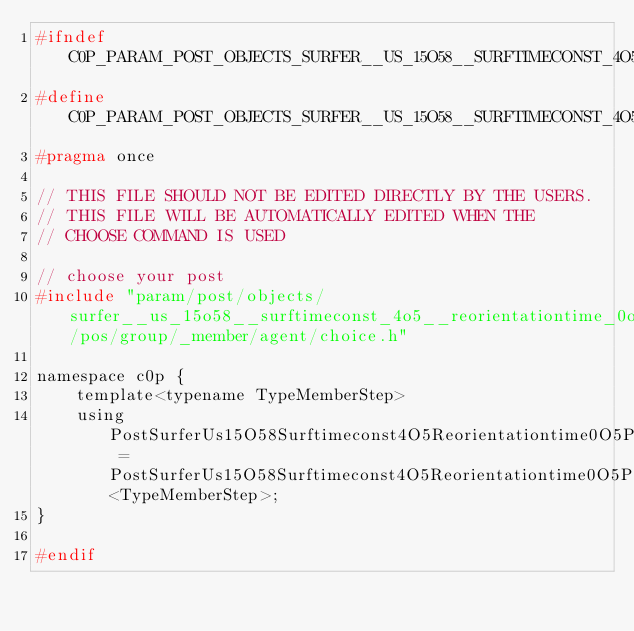<code> <loc_0><loc_0><loc_500><loc_500><_C_>#ifndef C0P_PARAM_POST_OBJECTS_SURFER__US_15O58__SURFTIMECONST_4O5__REORIENTATIONTIME_0O5_POS_GROUP_MEMBER_CHOICE_H
#define C0P_PARAM_POST_OBJECTS_SURFER__US_15O58__SURFTIMECONST_4O5__REORIENTATIONTIME_0O5_POS_GROUP_MEMBER_CHOICE_H
#pragma once

// THIS FILE SHOULD NOT BE EDITED DIRECTLY BY THE USERS.
// THIS FILE WILL BE AUTOMATICALLY EDITED WHEN THE
// CHOOSE COMMAND IS USED

// choose your post
#include "param/post/objects/surfer__us_15o58__surftimeconst_4o5__reorientationtime_0o5/pos/group/_member/agent/choice.h"

namespace c0p {
    template<typename TypeMemberStep>
    using PostSurferUs15O58Surftimeconst4O5Reorientationtime0O5PosGroupMember = PostSurferUs15O58Surftimeconst4O5Reorientationtime0O5PosGroupMemberAgent<TypeMemberStep>;
}

#endif
</code> 